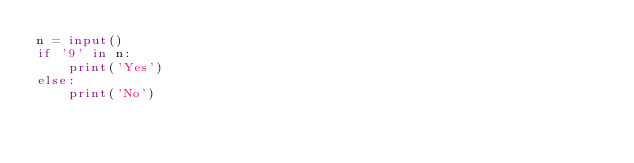Convert code to text. <code><loc_0><loc_0><loc_500><loc_500><_Python_>n = input()
if '9' in n:
    print('Yes')
else:
    print('No')</code> 